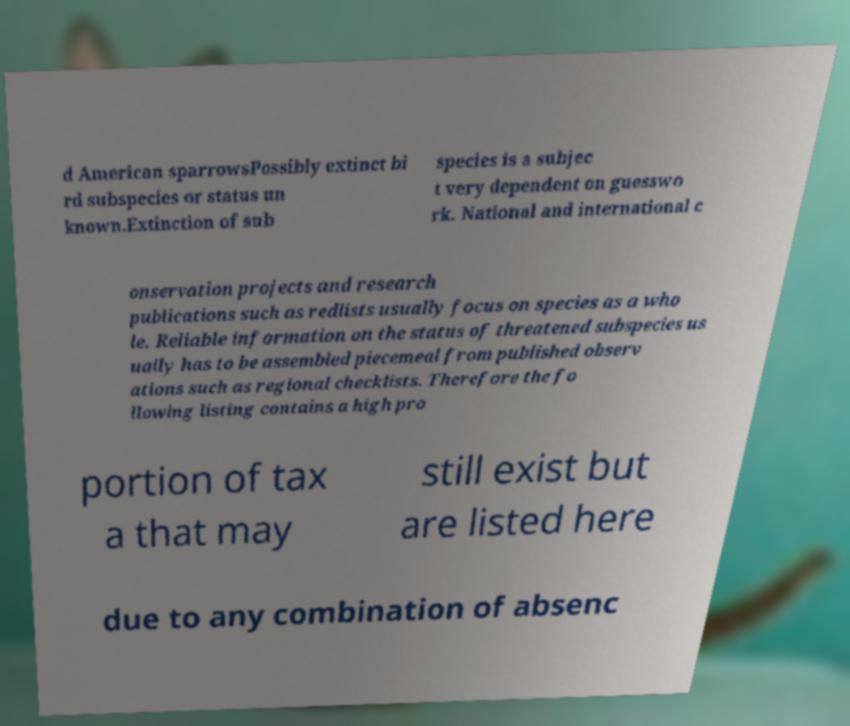Can you accurately transcribe the text from the provided image for me? d American sparrowsPossibly extinct bi rd subspecies or status un known.Extinction of sub species is a subjec t very dependent on guesswo rk. National and international c onservation projects and research publications such as redlists usually focus on species as a who le. Reliable information on the status of threatened subspecies us ually has to be assembled piecemeal from published observ ations such as regional checklists. Therefore the fo llowing listing contains a high pro portion of tax a that may still exist but are listed here due to any combination of absenc 